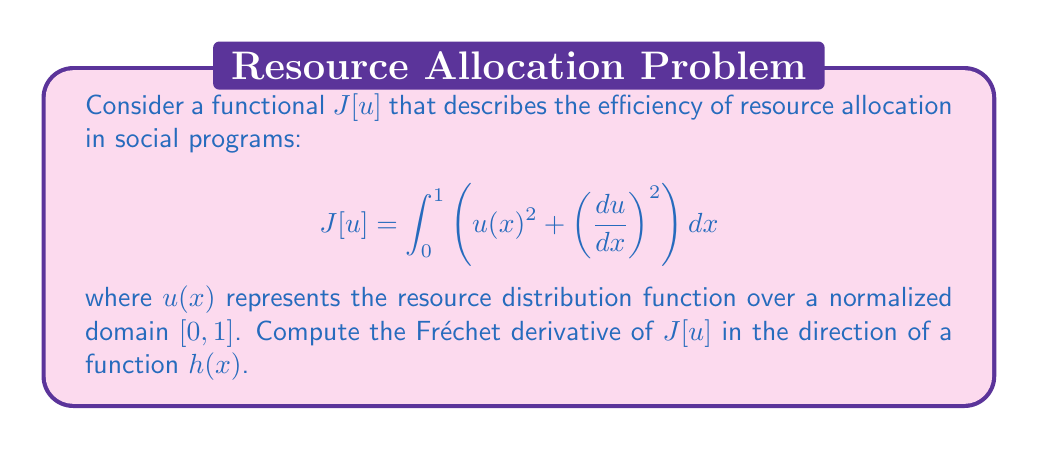Show me your answer to this math problem. To compute the Fréchet derivative of $J[u]$ in the direction of $h(x)$, we follow these steps:

1) The Fréchet derivative is defined as the linear part of the change in $J[u]$ when we perturb $u$ by a small amount in the direction of $h$. Mathematically, we can express this as:

   $$DJ[u](h) = \lim_{\epsilon \to 0} \frac{J[u + \epsilon h] - J[u]}{\epsilon}$$

2) Let's expand $J[u + \epsilon h]$:

   $$J[u + \epsilon h] = \int_0^1 \left((u(x) + \epsilon h(x))^2 + \left(\frac{d(u+\epsilon h)}{dx}\right)^2\right) dx$$

3) Expanding the squared terms:

   $$J[u + \epsilon h] = \int_0^1 \left(u(x)^2 + 2\epsilon u(x)h(x) + \epsilon^2 h(x)^2 + \left(\frac{du}{dx}\right)^2 + 2\epsilon \frac{du}{dx}\frac{dh}{dx} + \epsilon^2 \left(\frac{dh}{dx}\right)^2\right) dx$$

4) Now, let's subtract $J[u]$ and divide by $\epsilon$:

   $$\frac{J[u + \epsilon h] - J[u]}{\epsilon} = \int_0^1 \left(2u(x)h(x) + \epsilon h(x)^2 + 2\frac{du}{dx}\frac{dh}{dx} + \epsilon \left(\frac{dh}{dx}\right)^2\right) dx$$

5) Taking the limit as $\epsilon \to 0$, we get the Fréchet derivative:

   $$DJ[u](h) = \int_0^1 \left(2u(x)h(x) + 2\frac{du}{dx}\frac{dh}{dx}\right) dx$$

6) We can rewrite this using integration by parts on the second term:

   $$DJ[u](h) = \int_0^1 \left(2u(x)h(x) - 2\frac{d^2u}{dx^2}h(x)\right) dx + \left[2\frac{du}{dx}h(x)\right]_0^1$$

7) Assuming that $h(0) = h(1) = 0$ (which is typical for variations in calculus of variations problems), the boundary term vanishes, leaving us with:

   $$DJ[u](h) = \int_0^1 \left(2u(x) - 2\frac{d^2u}{dx^2}\right)h(x) dx$$

This is the Fréchet derivative of $J[u]$ in the direction of $h(x)$.
Answer: The Fréchet derivative of $J[u]$ in the direction of $h(x)$ is:

$$DJ[u](h) = \int_0^1 \left(2u(x) - 2\frac{d^2u}{dx^2}\right)h(x) dx$$ 